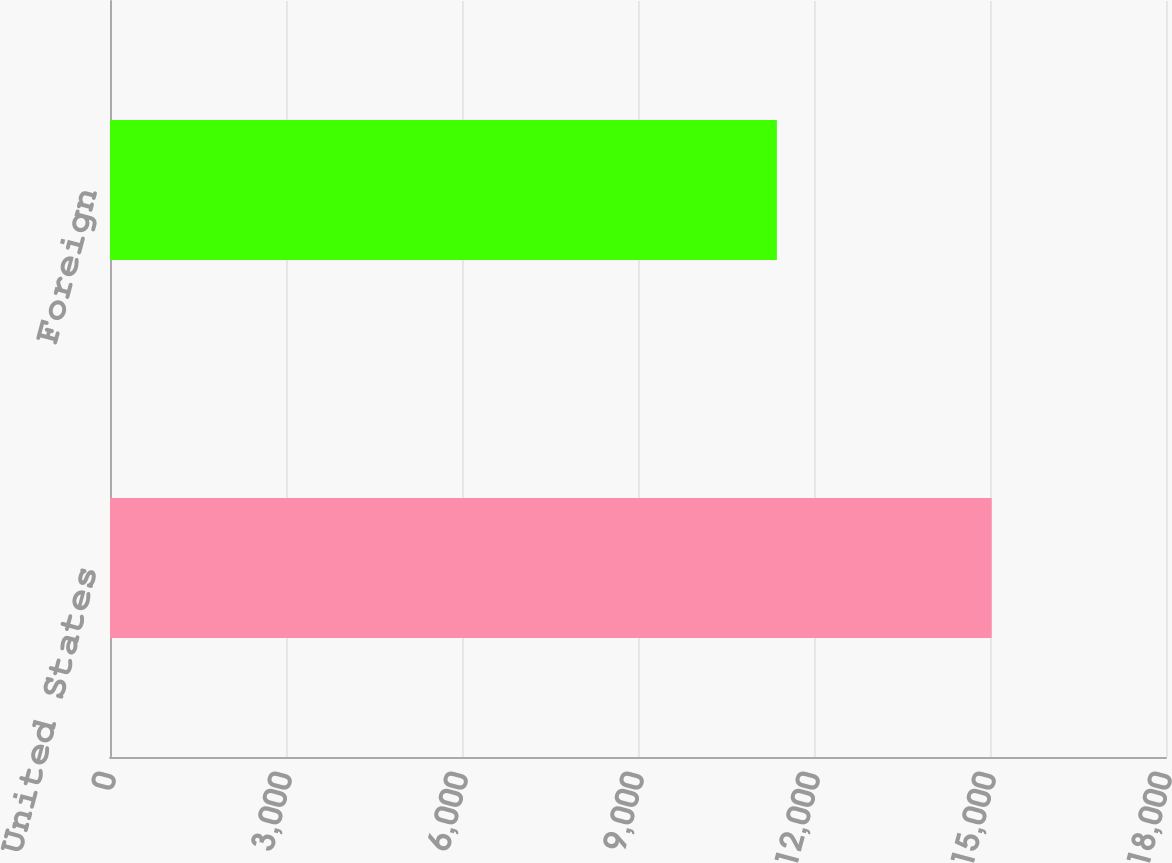<chart> <loc_0><loc_0><loc_500><loc_500><bar_chart><fcel>United States<fcel>Foreign<nl><fcel>15029<fcel>11367<nl></chart> 